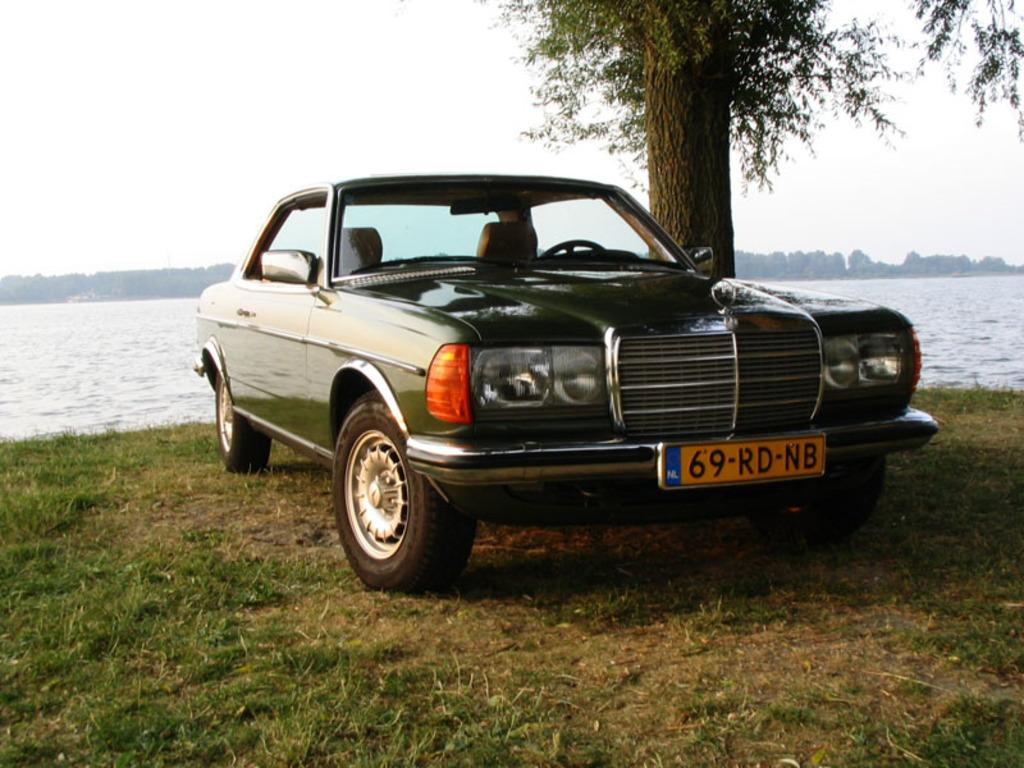What is located in the front of the image? There is a vehicle and a tree in the front of the image. What type of vegetation is present in the front of the image? There is grass in the front of the image. What can be seen in the background of the image? There are trees, water, and the sky visible in the background of the image. Where is the stove located in the image? There is no stove present in the image. What type of picture is hanging on the tree in the image? There is no picture hanging on the tree in the image. 